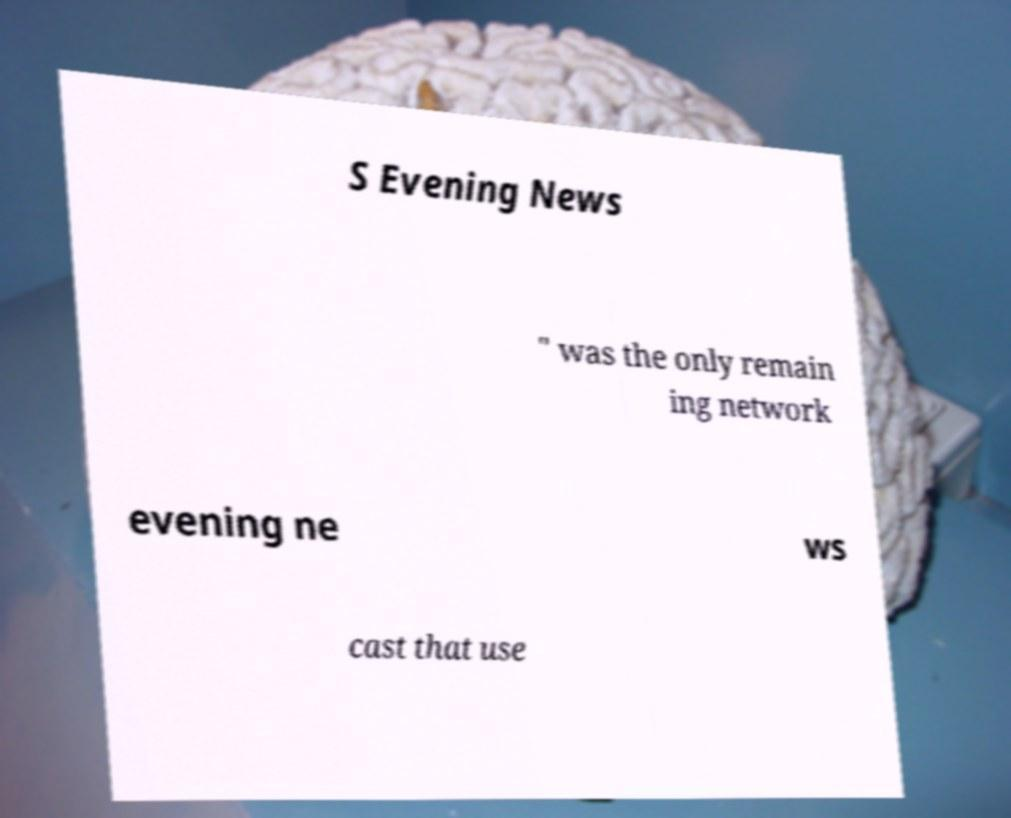Can you accurately transcribe the text from the provided image for me? S Evening News " was the only remain ing network evening ne ws cast that use 